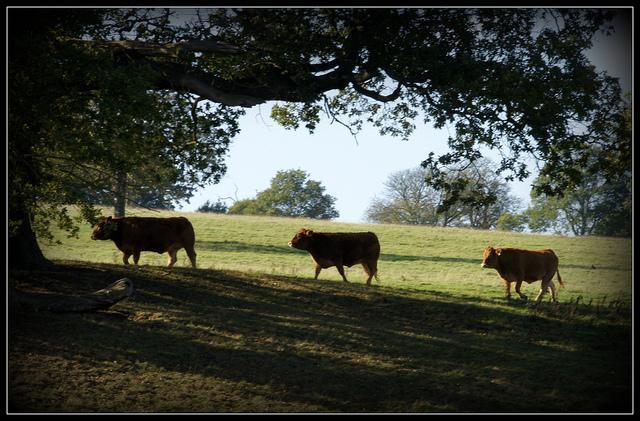How many cows are there?
Give a very brief answer. 3. 